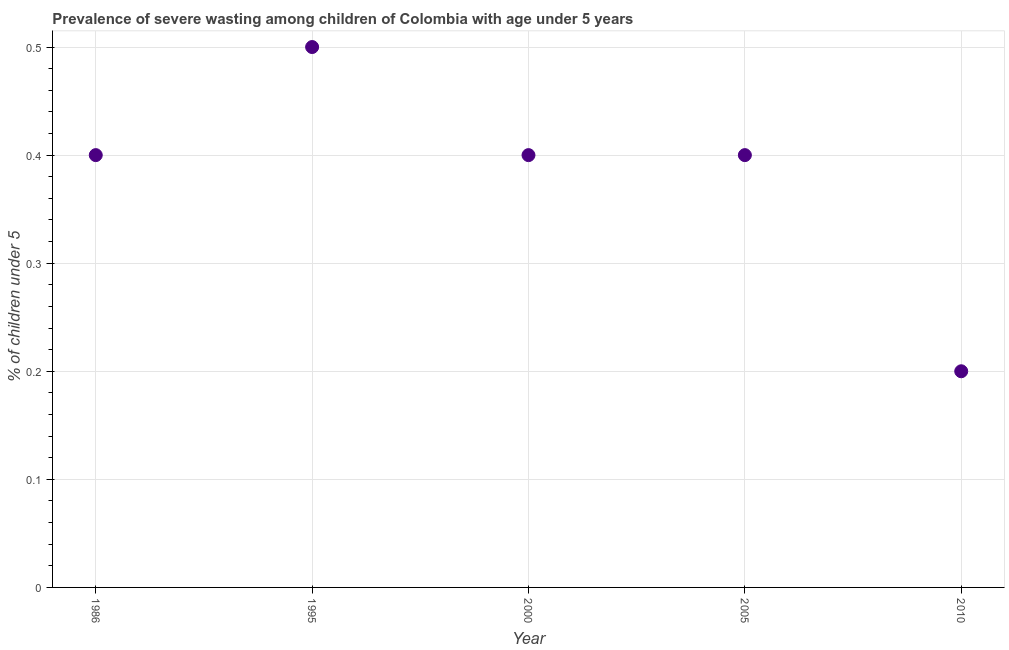What is the prevalence of severe wasting in 2005?
Offer a very short reply. 0.4. Across all years, what is the maximum prevalence of severe wasting?
Ensure brevity in your answer.  0.5. Across all years, what is the minimum prevalence of severe wasting?
Keep it short and to the point. 0.2. What is the sum of the prevalence of severe wasting?
Your answer should be compact. 1.9. What is the difference between the prevalence of severe wasting in 2005 and 2010?
Ensure brevity in your answer.  0.2. What is the average prevalence of severe wasting per year?
Provide a succinct answer. 0.38. What is the median prevalence of severe wasting?
Ensure brevity in your answer.  0.4. In how many years, is the prevalence of severe wasting greater than 0.16 %?
Give a very brief answer. 5. What is the ratio of the prevalence of severe wasting in 1995 to that in 2010?
Give a very brief answer. 2.5. Is the prevalence of severe wasting in 2005 less than that in 2010?
Offer a terse response. No. What is the difference between the highest and the second highest prevalence of severe wasting?
Offer a terse response. 0.1. Is the sum of the prevalence of severe wasting in 1986 and 2005 greater than the maximum prevalence of severe wasting across all years?
Provide a short and direct response. Yes. What is the difference between the highest and the lowest prevalence of severe wasting?
Provide a short and direct response. 0.3. How many years are there in the graph?
Your response must be concise. 5. What is the difference between two consecutive major ticks on the Y-axis?
Ensure brevity in your answer.  0.1. Are the values on the major ticks of Y-axis written in scientific E-notation?
Give a very brief answer. No. Does the graph contain grids?
Provide a short and direct response. Yes. What is the title of the graph?
Offer a terse response. Prevalence of severe wasting among children of Colombia with age under 5 years. What is the label or title of the X-axis?
Your answer should be very brief. Year. What is the label or title of the Y-axis?
Keep it short and to the point.  % of children under 5. What is the  % of children under 5 in 1986?
Your answer should be very brief. 0.4. What is the  % of children under 5 in 1995?
Offer a very short reply. 0.5. What is the  % of children under 5 in 2000?
Make the answer very short. 0.4. What is the  % of children under 5 in 2005?
Keep it short and to the point. 0.4. What is the  % of children under 5 in 2010?
Provide a succinct answer. 0.2. What is the difference between the  % of children under 5 in 1986 and 2005?
Ensure brevity in your answer.  0. What is the difference between the  % of children under 5 in 1995 and 2005?
Ensure brevity in your answer.  0.1. What is the difference between the  % of children under 5 in 1995 and 2010?
Your response must be concise. 0.3. What is the difference between the  % of children under 5 in 2000 and 2005?
Offer a very short reply. 0. What is the ratio of the  % of children under 5 in 1986 to that in 1995?
Make the answer very short. 0.8. What is the ratio of the  % of children under 5 in 1986 to that in 2000?
Your answer should be compact. 1. What is the ratio of the  % of children under 5 in 1986 to that in 2005?
Make the answer very short. 1. What is the ratio of the  % of children under 5 in 1986 to that in 2010?
Your answer should be compact. 2. What is the ratio of the  % of children under 5 in 1995 to that in 2000?
Your response must be concise. 1.25. What is the ratio of the  % of children under 5 in 1995 to that in 2005?
Provide a succinct answer. 1.25. What is the ratio of the  % of children under 5 in 2000 to that in 2005?
Your answer should be very brief. 1. 